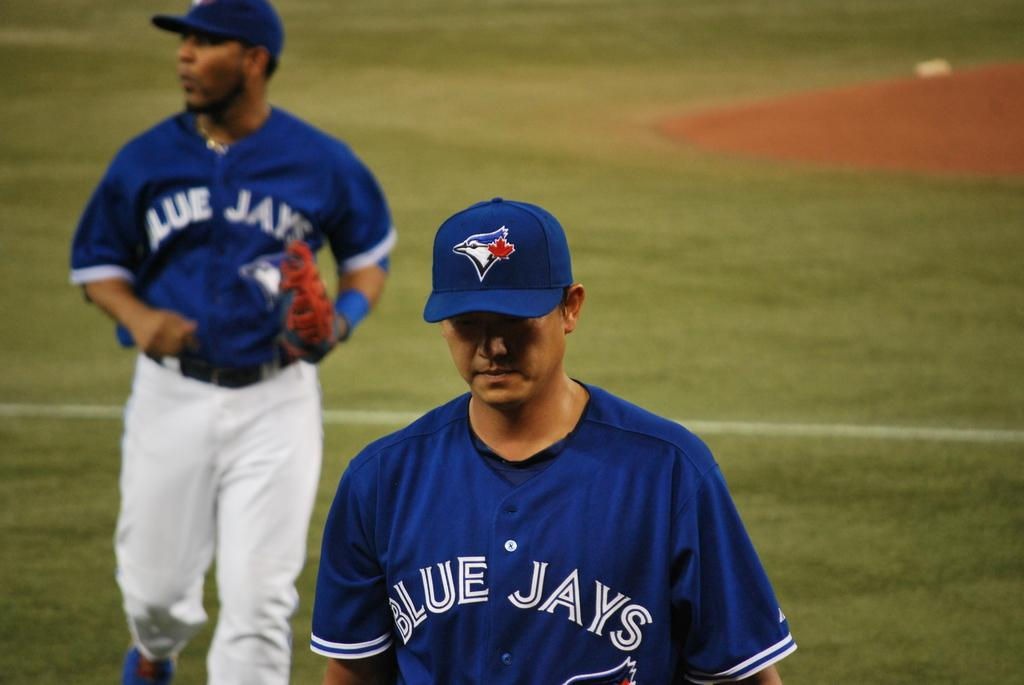<image>
Render a clear and concise summary of the photo. Two base ball players with blue and white uniforms have the name blue jays on their chests. 